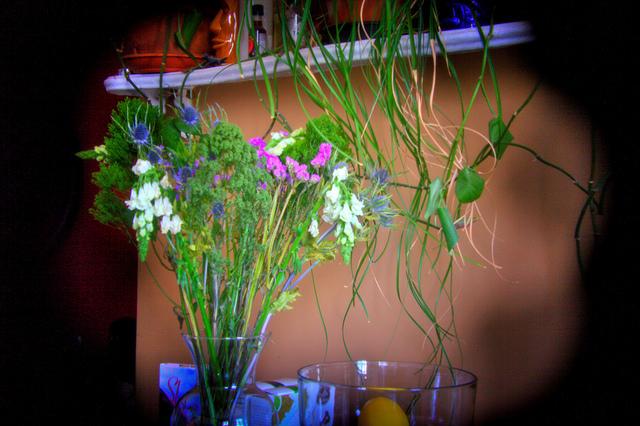Is there any living thing in this image?
Write a very short answer. Yes. Is this a wildflower?
Short answer required. Yes. What color is the wall?
Concise answer only. Brown. What color is the face above the flowers?
Answer briefly. Red. 